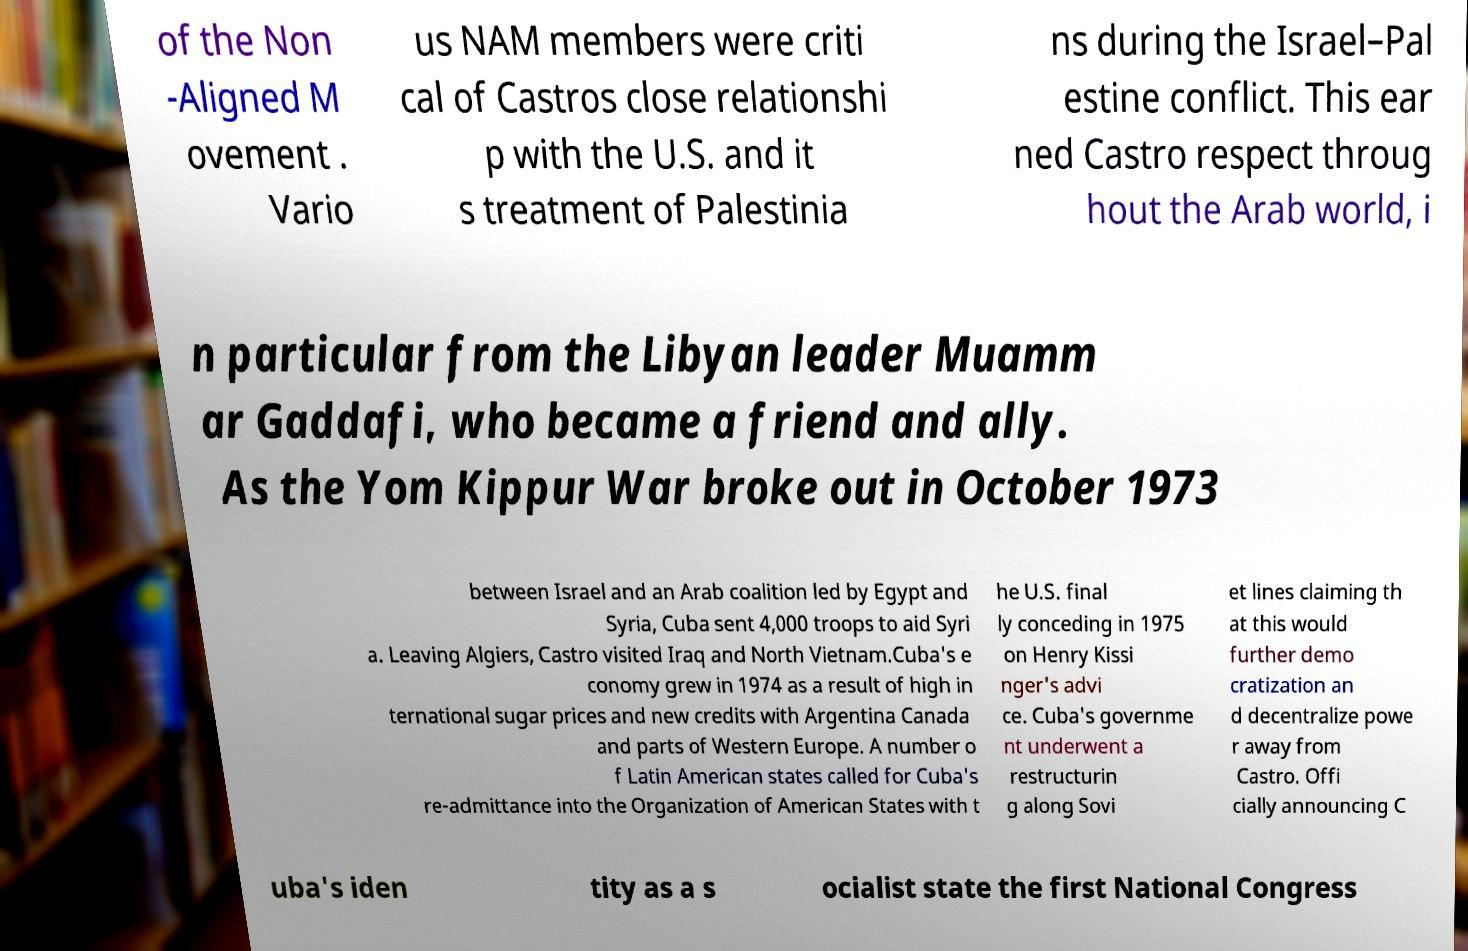There's text embedded in this image that I need extracted. Can you transcribe it verbatim? of the Non -Aligned M ovement . Vario us NAM members were criti cal of Castros close relationshi p with the U.S. and it s treatment of Palestinia ns during the Israel–Pal estine conflict. This ear ned Castro respect throug hout the Arab world, i n particular from the Libyan leader Muamm ar Gaddafi, who became a friend and ally. As the Yom Kippur War broke out in October 1973 between Israel and an Arab coalition led by Egypt and Syria, Cuba sent 4,000 troops to aid Syri a. Leaving Algiers, Castro visited Iraq and North Vietnam.Cuba's e conomy grew in 1974 as a result of high in ternational sugar prices and new credits with Argentina Canada and parts of Western Europe. A number o f Latin American states called for Cuba's re-admittance into the Organization of American States with t he U.S. final ly conceding in 1975 on Henry Kissi nger's advi ce. Cuba's governme nt underwent a restructurin g along Sovi et lines claiming th at this would further demo cratization an d decentralize powe r away from Castro. Offi cially announcing C uba's iden tity as a s ocialist state the first National Congress 